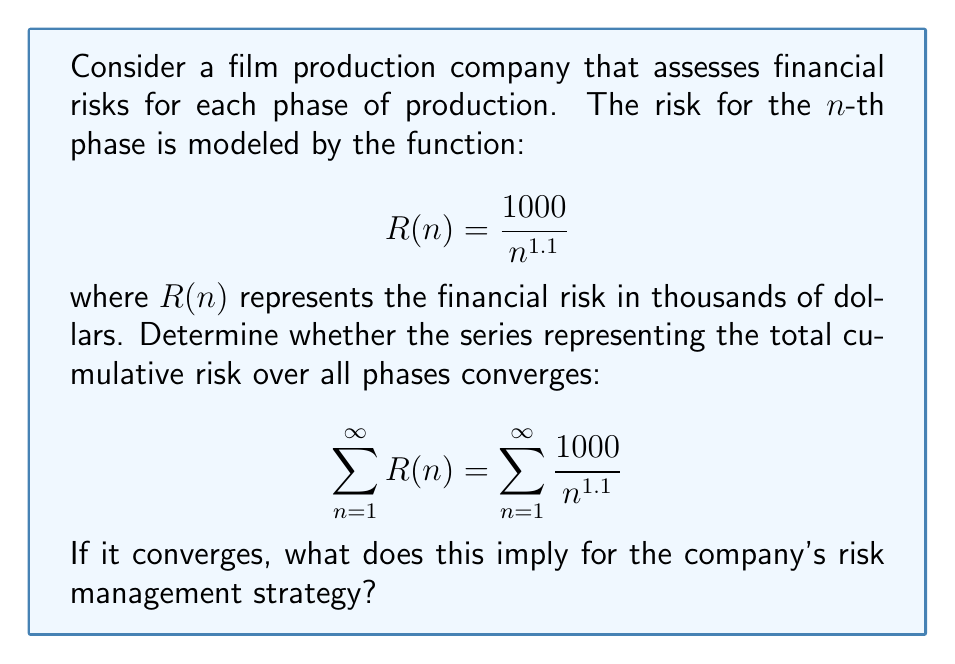Teach me how to tackle this problem. To analyze the convergence of this series, we can use the p-series test:

1) The general form of a p-series is $\sum_{n=1}^{\infty} \frac{1}{n^p}$

2) Our series can be rewritten as $1000 \sum_{n=1}^{\infty} \frac{1}{n^{1.1}}$

3) The constant 1000 doesn't affect convergence, so we focus on $\sum_{n=1}^{\infty} \frac{1}{n^{1.1}}$

4) For a p-series:
   - If $p > 1$, the series converges
   - If $p \leq 1$, the series diverges

5) In our case, $p = 1.1$

6) Since $1.1 > 1$, the series converges

7) The convergence implies that the total cumulative risk over all phases is finite and bounded.

For the company's risk management strategy, this means:
a) The total financial risk across all production phases has an upper limit
b) Later production phases contribute progressively less to the overall risk
c) Risk mitigation efforts can focus on earlier phases for maximum impact
d) Long-term financial planning can be based on a calculable maximum risk
Answer: The series converges. This implies a finite total risk with diminishing contributions from later phases, allowing for focused risk management on earlier stages. 